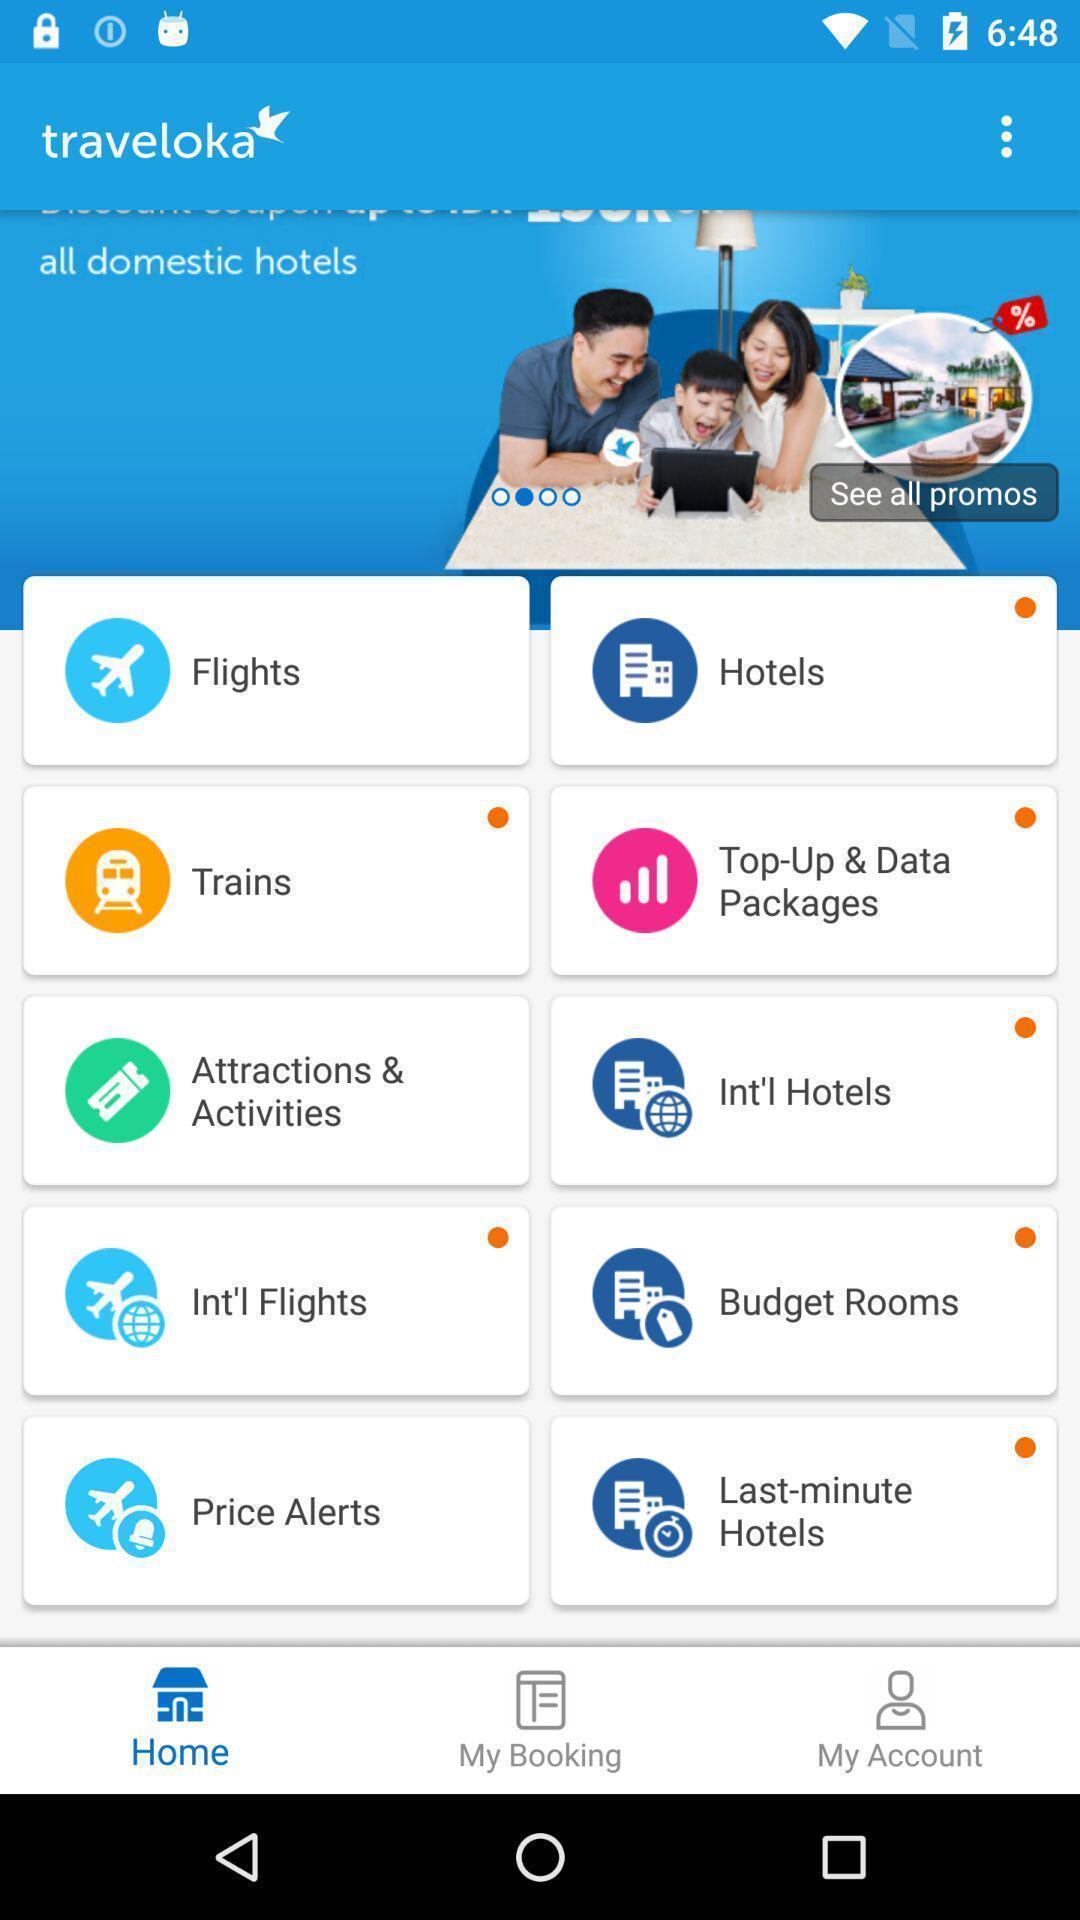Describe the key features of this screenshot. Screen shows list of options in a travel app. 